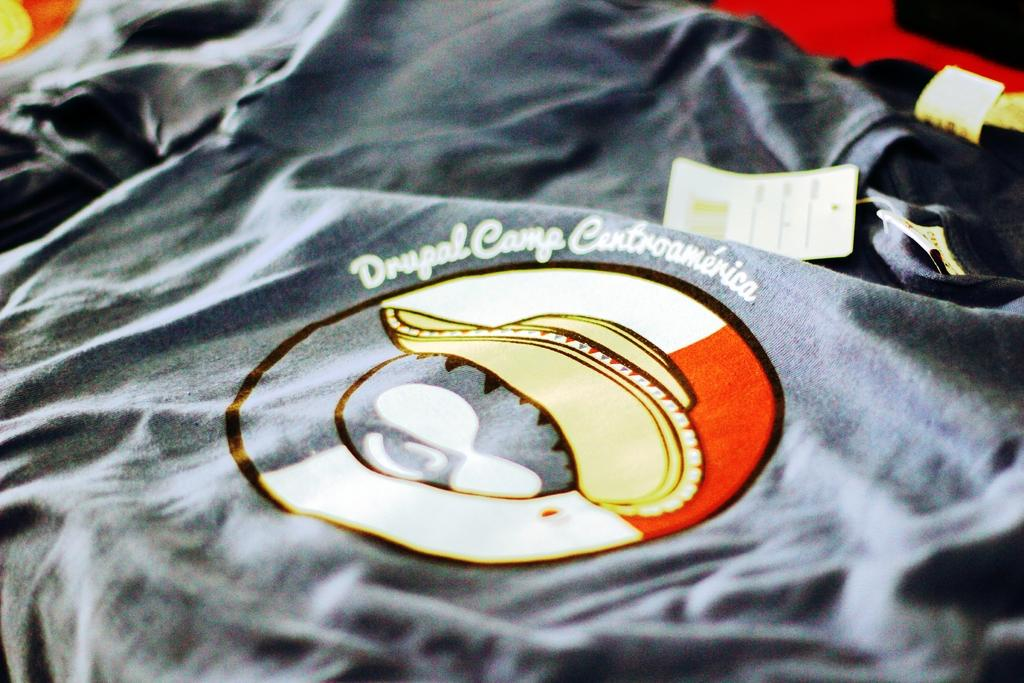What type of clothing item is visible in the image? There is a black t-shirt in the image. Are there any additional features on the t-shirt? Yes, the t-shirt has tags. What is depicted on the t-shirt? There is a picture of a hat on the t-shirt. What type of paint is used to create the picture of the hat on the t-shirt? There is no information about the type of paint used to create the picture of the hat on the t-shirt. 